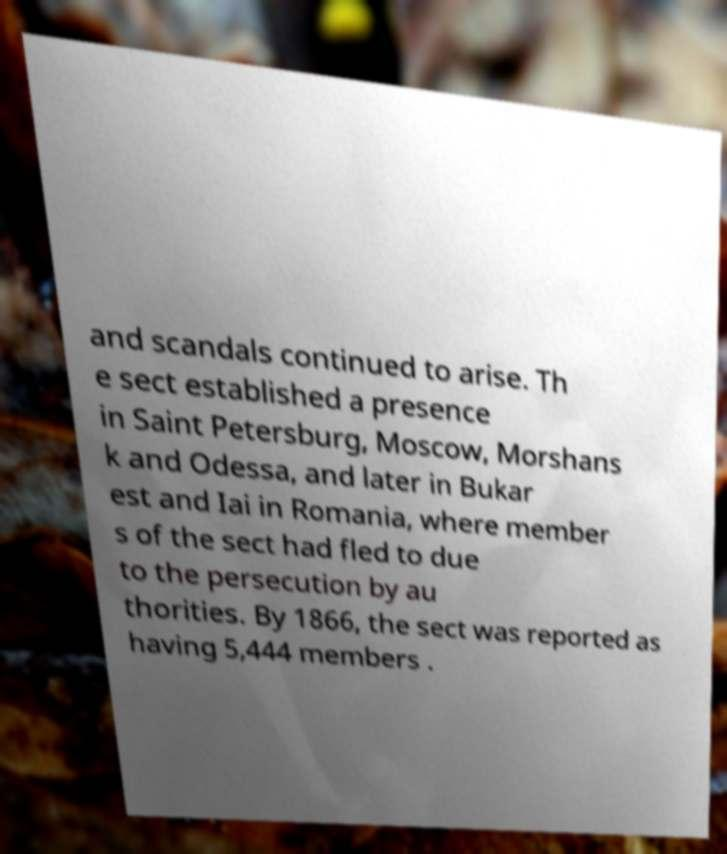What messages or text are displayed in this image? I need them in a readable, typed format. and scandals continued to arise. Th e sect established a presence in Saint Petersburg, Moscow, Morshans k and Odessa, and later in Bukar est and Iai in Romania, where member s of the sect had fled to due to the persecution by au thorities. By 1866, the sect was reported as having 5,444 members . 